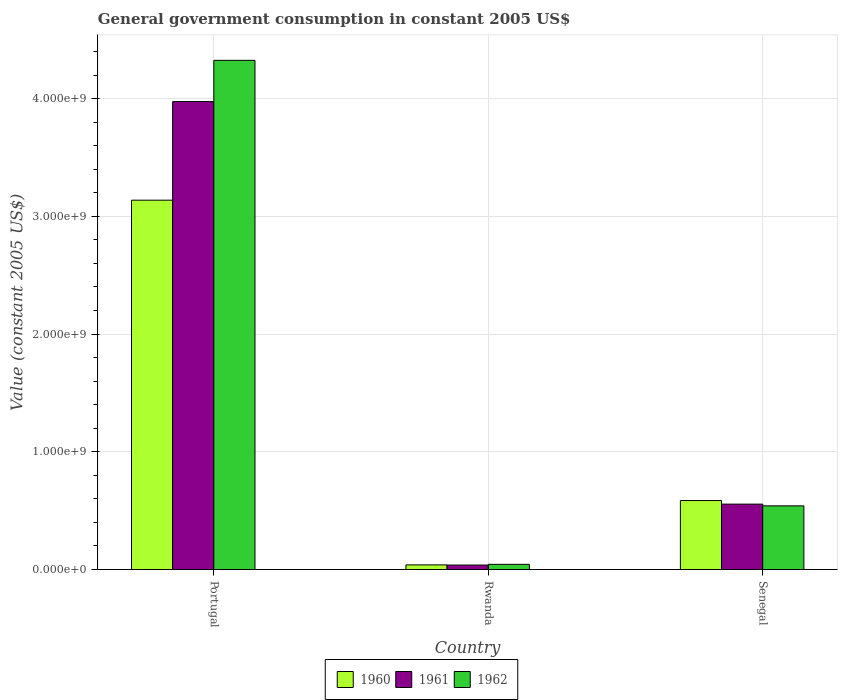How many different coloured bars are there?
Your answer should be compact. 3. How many groups of bars are there?
Offer a terse response. 3. Are the number of bars per tick equal to the number of legend labels?
Provide a succinct answer. Yes. Are the number of bars on each tick of the X-axis equal?
Ensure brevity in your answer.  Yes. What is the label of the 1st group of bars from the left?
Your answer should be compact. Portugal. In how many cases, is the number of bars for a given country not equal to the number of legend labels?
Provide a short and direct response. 0. What is the government conusmption in 1962 in Rwanda?
Offer a very short reply. 4.39e+07. Across all countries, what is the maximum government conusmption in 1960?
Give a very brief answer. 3.14e+09. Across all countries, what is the minimum government conusmption in 1960?
Provide a short and direct response. 3.93e+07. In which country was the government conusmption in 1962 maximum?
Your response must be concise. Portugal. In which country was the government conusmption in 1962 minimum?
Your answer should be compact. Rwanda. What is the total government conusmption in 1961 in the graph?
Keep it short and to the point. 4.57e+09. What is the difference between the government conusmption in 1962 in Portugal and that in Rwanda?
Provide a short and direct response. 4.28e+09. What is the difference between the government conusmption in 1961 in Senegal and the government conusmption in 1962 in Rwanda?
Provide a short and direct response. 5.11e+08. What is the average government conusmption in 1962 per country?
Make the answer very short. 1.64e+09. What is the difference between the government conusmption of/in 1961 and government conusmption of/in 1960 in Rwanda?
Offer a terse response. -1.39e+06. What is the ratio of the government conusmption in 1960 in Portugal to that in Senegal?
Your response must be concise. 5.35. Is the government conusmption in 1962 in Portugal less than that in Senegal?
Offer a very short reply. No. What is the difference between the highest and the second highest government conusmption in 1961?
Offer a very short reply. 3.94e+09. What is the difference between the highest and the lowest government conusmption in 1962?
Provide a succinct answer. 4.28e+09. In how many countries, is the government conusmption in 1960 greater than the average government conusmption in 1960 taken over all countries?
Provide a succinct answer. 1. Is the sum of the government conusmption in 1960 in Portugal and Senegal greater than the maximum government conusmption in 1962 across all countries?
Provide a succinct answer. No. What does the 3rd bar from the left in Senegal represents?
Ensure brevity in your answer.  1962. What does the 1st bar from the right in Portugal represents?
Provide a short and direct response. 1962. Is it the case that in every country, the sum of the government conusmption in 1961 and government conusmption in 1962 is greater than the government conusmption in 1960?
Offer a very short reply. Yes. How many bars are there?
Ensure brevity in your answer.  9. What is the difference between two consecutive major ticks on the Y-axis?
Offer a terse response. 1.00e+09. Are the values on the major ticks of Y-axis written in scientific E-notation?
Give a very brief answer. Yes. Does the graph contain any zero values?
Ensure brevity in your answer.  No. Does the graph contain grids?
Offer a terse response. Yes. Where does the legend appear in the graph?
Give a very brief answer. Bottom center. How are the legend labels stacked?
Keep it short and to the point. Horizontal. What is the title of the graph?
Your response must be concise. General government consumption in constant 2005 US$. Does "1973" appear as one of the legend labels in the graph?
Your answer should be compact. No. What is the label or title of the Y-axis?
Make the answer very short. Value (constant 2005 US$). What is the Value (constant 2005 US$) in 1960 in Portugal?
Offer a very short reply. 3.14e+09. What is the Value (constant 2005 US$) of 1961 in Portugal?
Offer a terse response. 3.97e+09. What is the Value (constant 2005 US$) in 1962 in Portugal?
Your answer should be very brief. 4.32e+09. What is the Value (constant 2005 US$) of 1960 in Rwanda?
Offer a very short reply. 3.93e+07. What is the Value (constant 2005 US$) of 1961 in Rwanda?
Your answer should be compact. 3.79e+07. What is the Value (constant 2005 US$) in 1962 in Rwanda?
Ensure brevity in your answer.  4.39e+07. What is the Value (constant 2005 US$) of 1960 in Senegal?
Your answer should be very brief. 5.86e+08. What is the Value (constant 2005 US$) of 1961 in Senegal?
Give a very brief answer. 5.55e+08. What is the Value (constant 2005 US$) in 1962 in Senegal?
Your answer should be very brief. 5.41e+08. Across all countries, what is the maximum Value (constant 2005 US$) of 1960?
Keep it short and to the point. 3.14e+09. Across all countries, what is the maximum Value (constant 2005 US$) in 1961?
Ensure brevity in your answer.  3.97e+09. Across all countries, what is the maximum Value (constant 2005 US$) of 1962?
Ensure brevity in your answer.  4.32e+09. Across all countries, what is the minimum Value (constant 2005 US$) in 1960?
Your answer should be very brief. 3.93e+07. Across all countries, what is the minimum Value (constant 2005 US$) in 1961?
Give a very brief answer. 3.79e+07. Across all countries, what is the minimum Value (constant 2005 US$) of 1962?
Give a very brief answer. 4.39e+07. What is the total Value (constant 2005 US$) in 1960 in the graph?
Ensure brevity in your answer.  3.76e+09. What is the total Value (constant 2005 US$) of 1961 in the graph?
Make the answer very short. 4.57e+09. What is the total Value (constant 2005 US$) in 1962 in the graph?
Give a very brief answer. 4.91e+09. What is the difference between the Value (constant 2005 US$) in 1960 in Portugal and that in Rwanda?
Provide a short and direct response. 3.10e+09. What is the difference between the Value (constant 2005 US$) in 1961 in Portugal and that in Rwanda?
Give a very brief answer. 3.94e+09. What is the difference between the Value (constant 2005 US$) in 1962 in Portugal and that in Rwanda?
Ensure brevity in your answer.  4.28e+09. What is the difference between the Value (constant 2005 US$) of 1960 in Portugal and that in Senegal?
Keep it short and to the point. 2.55e+09. What is the difference between the Value (constant 2005 US$) of 1961 in Portugal and that in Senegal?
Provide a succinct answer. 3.42e+09. What is the difference between the Value (constant 2005 US$) in 1962 in Portugal and that in Senegal?
Your response must be concise. 3.78e+09. What is the difference between the Value (constant 2005 US$) in 1960 in Rwanda and that in Senegal?
Keep it short and to the point. -5.47e+08. What is the difference between the Value (constant 2005 US$) of 1961 in Rwanda and that in Senegal?
Ensure brevity in your answer.  -5.17e+08. What is the difference between the Value (constant 2005 US$) in 1962 in Rwanda and that in Senegal?
Offer a very short reply. -4.97e+08. What is the difference between the Value (constant 2005 US$) in 1960 in Portugal and the Value (constant 2005 US$) in 1961 in Rwanda?
Offer a terse response. 3.10e+09. What is the difference between the Value (constant 2005 US$) of 1960 in Portugal and the Value (constant 2005 US$) of 1962 in Rwanda?
Your answer should be compact. 3.09e+09. What is the difference between the Value (constant 2005 US$) of 1961 in Portugal and the Value (constant 2005 US$) of 1962 in Rwanda?
Offer a very short reply. 3.93e+09. What is the difference between the Value (constant 2005 US$) in 1960 in Portugal and the Value (constant 2005 US$) in 1961 in Senegal?
Offer a very short reply. 2.58e+09. What is the difference between the Value (constant 2005 US$) of 1960 in Portugal and the Value (constant 2005 US$) of 1962 in Senegal?
Provide a short and direct response. 2.60e+09. What is the difference between the Value (constant 2005 US$) of 1961 in Portugal and the Value (constant 2005 US$) of 1962 in Senegal?
Make the answer very short. 3.43e+09. What is the difference between the Value (constant 2005 US$) of 1960 in Rwanda and the Value (constant 2005 US$) of 1961 in Senegal?
Make the answer very short. -5.16e+08. What is the difference between the Value (constant 2005 US$) of 1960 in Rwanda and the Value (constant 2005 US$) of 1962 in Senegal?
Make the answer very short. -5.01e+08. What is the difference between the Value (constant 2005 US$) in 1961 in Rwanda and the Value (constant 2005 US$) in 1962 in Senegal?
Provide a short and direct response. -5.03e+08. What is the average Value (constant 2005 US$) in 1960 per country?
Provide a succinct answer. 1.25e+09. What is the average Value (constant 2005 US$) of 1961 per country?
Give a very brief answer. 1.52e+09. What is the average Value (constant 2005 US$) in 1962 per country?
Keep it short and to the point. 1.64e+09. What is the difference between the Value (constant 2005 US$) in 1960 and Value (constant 2005 US$) in 1961 in Portugal?
Your answer should be compact. -8.38e+08. What is the difference between the Value (constant 2005 US$) of 1960 and Value (constant 2005 US$) of 1962 in Portugal?
Ensure brevity in your answer.  -1.19e+09. What is the difference between the Value (constant 2005 US$) in 1961 and Value (constant 2005 US$) in 1962 in Portugal?
Your answer should be compact. -3.50e+08. What is the difference between the Value (constant 2005 US$) of 1960 and Value (constant 2005 US$) of 1961 in Rwanda?
Offer a very short reply. 1.39e+06. What is the difference between the Value (constant 2005 US$) in 1960 and Value (constant 2005 US$) in 1962 in Rwanda?
Your answer should be compact. -4.55e+06. What is the difference between the Value (constant 2005 US$) of 1961 and Value (constant 2005 US$) of 1962 in Rwanda?
Your answer should be very brief. -5.95e+06. What is the difference between the Value (constant 2005 US$) of 1960 and Value (constant 2005 US$) of 1961 in Senegal?
Give a very brief answer. 3.05e+07. What is the difference between the Value (constant 2005 US$) of 1960 and Value (constant 2005 US$) of 1962 in Senegal?
Provide a short and direct response. 4.51e+07. What is the difference between the Value (constant 2005 US$) of 1961 and Value (constant 2005 US$) of 1962 in Senegal?
Offer a terse response. 1.45e+07. What is the ratio of the Value (constant 2005 US$) in 1960 in Portugal to that in Rwanda?
Make the answer very short. 79.76. What is the ratio of the Value (constant 2005 US$) in 1961 in Portugal to that in Rwanda?
Your answer should be compact. 104.77. What is the ratio of the Value (constant 2005 US$) of 1962 in Portugal to that in Rwanda?
Provide a short and direct response. 98.56. What is the ratio of the Value (constant 2005 US$) in 1960 in Portugal to that in Senegal?
Offer a terse response. 5.35. What is the ratio of the Value (constant 2005 US$) in 1961 in Portugal to that in Senegal?
Give a very brief answer. 7.16. What is the ratio of the Value (constant 2005 US$) in 1962 in Portugal to that in Senegal?
Give a very brief answer. 8. What is the ratio of the Value (constant 2005 US$) of 1960 in Rwanda to that in Senegal?
Your answer should be compact. 0.07. What is the ratio of the Value (constant 2005 US$) of 1961 in Rwanda to that in Senegal?
Offer a terse response. 0.07. What is the ratio of the Value (constant 2005 US$) of 1962 in Rwanda to that in Senegal?
Ensure brevity in your answer.  0.08. What is the difference between the highest and the second highest Value (constant 2005 US$) in 1960?
Your answer should be compact. 2.55e+09. What is the difference between the highest and the second highest Value (constant 2005 US$) in 1961?
Your answer should be compact. 3.42e+09. What is the difference between the highest and the second highest Value (constant 2005 US$) in 1962?
Make the answer very short. 3.78e+09. What is the difference between the highest and the lowest Value (constant 2005 US$) in 1960?
Provide a succinct answer. 3.10e+09. What is the difference between the highest and the lowest Value (constant 2005 US$) in 1961?
Give a very brief answer. 3.94e+09. What is the difference between the highest and the lowest Value (constant 2005 US$) of 1962?
Your response must be concise. 4.28e+09. 